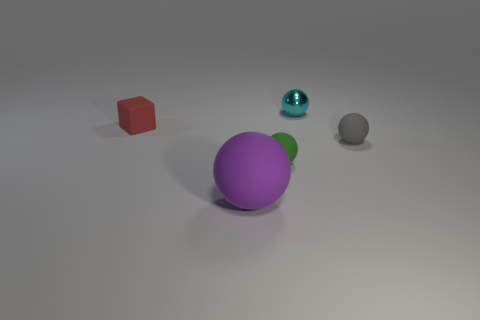The green sphere that is the same material as the large object is what size?
Offer a terse response. Small. Is the number of green rubber objects that are behind the small cyan metal thing greater than the number of large rubber things?
Your response must be concise. No. There is a red object; does it have the same shape as the tiny object in front of the gray thing?
Your answer should be very brief. No. What number of tiny things are brown cylinders or rubber objects?
Provide a short and direct response. 3. There is a small object in front of the tiny rubber thing right of the cyan metallic ball; what color is it?
Give a very brief answer. Green. Does the cube have the same material as the small ball that is on the right side of the shiny ball?
Your answer should be very brief. Yes. There is a ball to the right of the shiny thing; what is its material?
Your answer should be very brief. Rubber. Are there an equal number of tiny cyan metal things that are in front of the small cyan sphere and tiny things?
Offer a very short reply. No. Are there any other things that are the same size as the purple object?
Keep it short and to the point. No. There is a small object that is to the left of the sphere that is in front of the small green rubber thing; what is its material?
Ensure brevity in your answer.  Rubber. 